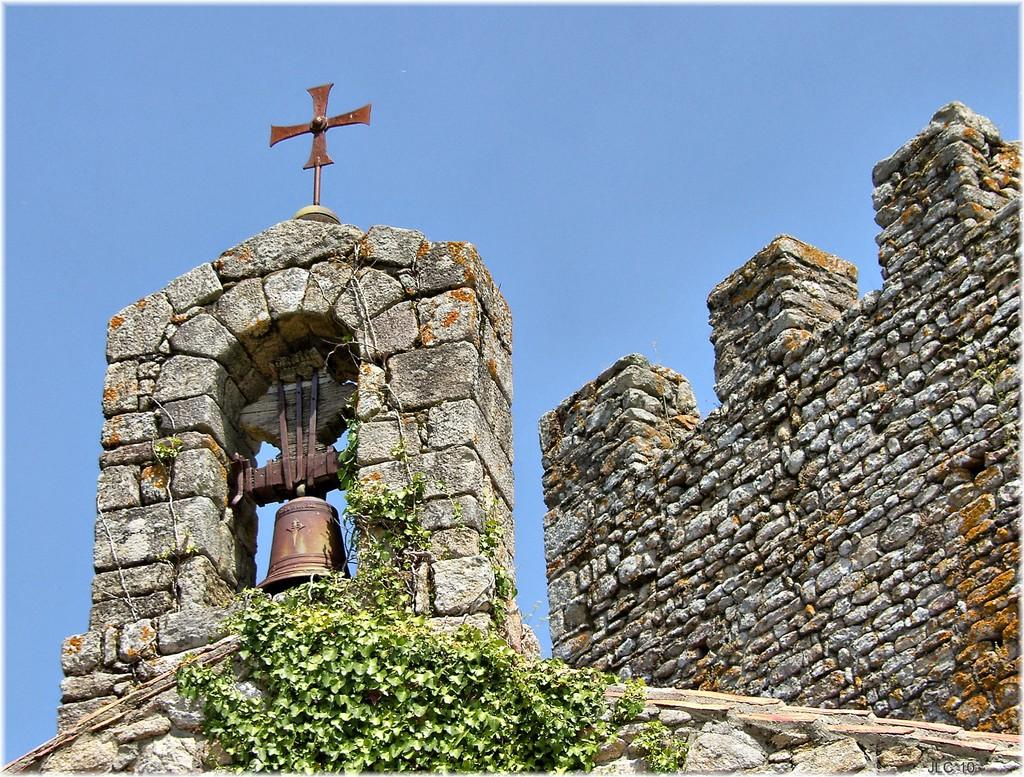What type of structure is present in the image? There is a stone wall in the image. Are there any plants growing on the wall? Yes, the wall has creepers on it. What is attached to the wall? A ball is attached to the wall. What else can be seen on the wall? There is an object on the wall. What can be seen in the background of the image? The sky is visible in the background of the image. What type of smoke can be seen coming from the object on the wall? There is no smoke present in the image; the object on the wall does not emit any smoke. What is the taste of the railway in the image? There is no railway present in the image, and therefore no taste can be associated with it. 